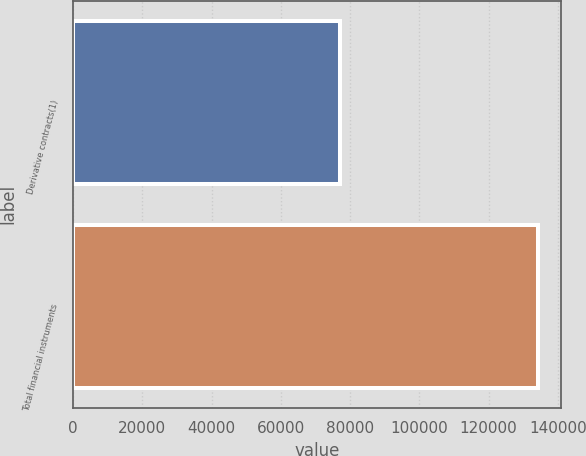Convert chart to OTSL. <chart><loc_0><loc_0><loc_500><loc_500><bar_chart><fcel>Derivative contracts(1)<fcel>Total financial instruments<nl><fcel>77003<fcel>134341<nl></chart> 